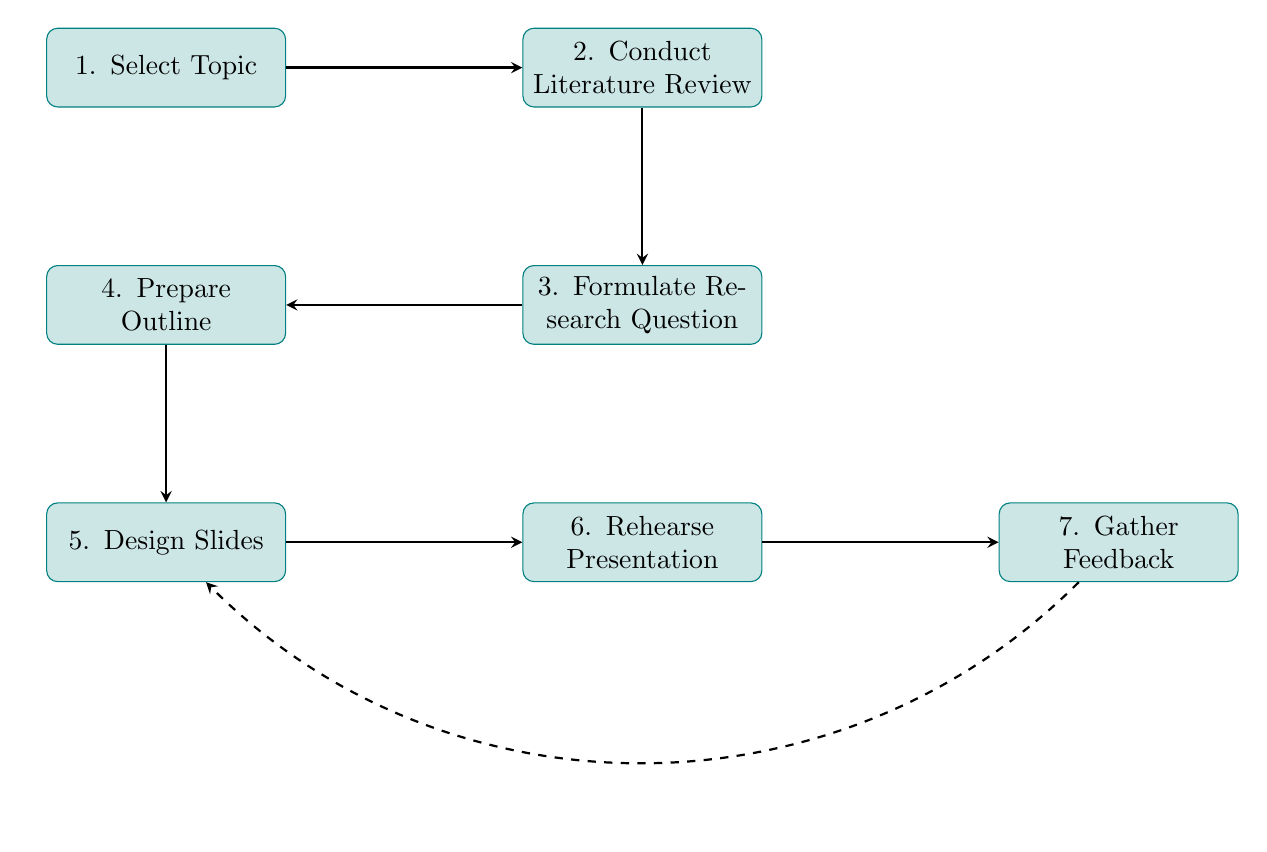What is the first step in the flow chart? The first step in the flow chart, as indicated by the starting node, is labeled "Select Topic."
Answer: Select Topic How many steps are there in total? By counting the nodes in the flow chart, there are a total of seven steps present.
Answer: 7 What follows the "Conduct Literature Review" step? The flow chart indicates that "Conduct Literature Review" is followed by the "Formulate Research Question" step.
Answer: Formulate Research Question Which step comes after designing the slides? The next step after "Design Slides" is "Rehearse Presentation," according to the flow of the chart.
Answer: Rehearse Presentation What is the last step in the flow chart? The diagram shows that the final step in the process is labeled "Gather Feedback."
Answer: Gather Feedback Why is "Prepare Outline" important in the sequence? "Prepare Outline" is crucial as it acts as a precursor to "Design Slides," helping to structure the content of the presentation and ensure that key points are covered.
Answer: It structures content Does the flow of the diagram suggest any iterative process? Yes, the dashed arrow indicates that after gathering feedback, you may return to the "Design Slides" step, allowing for revisions based on feedback received.
Answer: Yes, feedback iteration Which two steps are directly connected to the "Formulate Research Question" node? The "Conduct Literature Review" step is directly connected above it, and the "Prepare Outline" step is directly connected below it, indicating their sequential relationship.
Answer: Conduct Literature Review and Prepare Outline What is the primary focus of the initial step? The primary focus of the "Select Topic" step is to choose a relevant and impactful subject within the student's field of study.
Answer: Relevant and impactful topic 